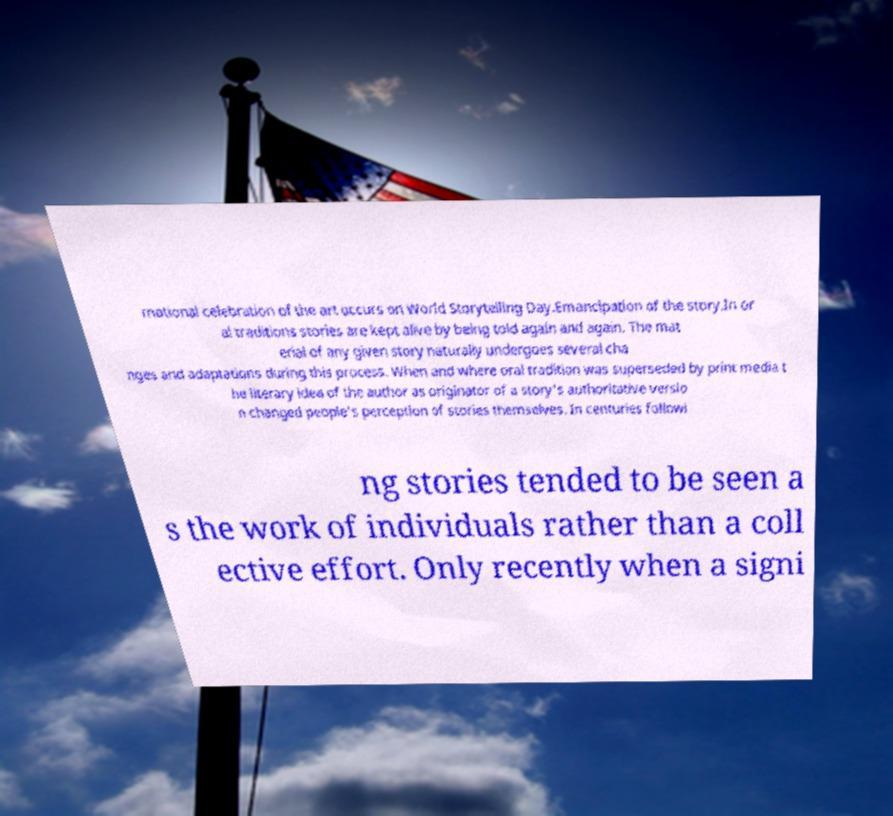Please read and relay the text visible in this image. What does it say? rnational celebration of the art occurs on World Storytelling Day.Emancipation of the story.In or al traditions stories are kept alive by being told again and again. The mat erial of any given story naturally undergoes several cha nges and adaptations during this process. When and where oral tradition was superseded by print media t he literary idea of the author as originator of a story's authoritative versio n changed people's perception of stories themselves. In centuries followi ng stories tended to be seen a s the work of individuals rather than a coll ective effort. Only recently when a signi 